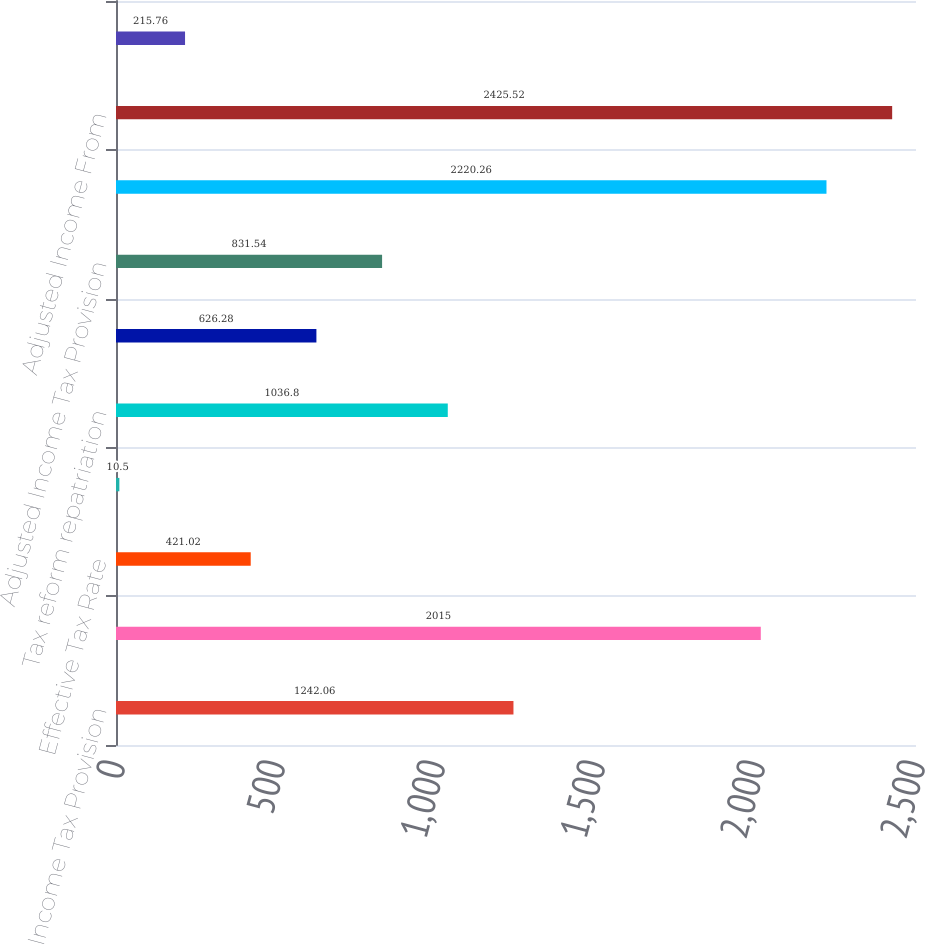Convert chart. <chart><loc_0><loc_0><loc_500><loc_500><bar_chart><fcel>Income Tax Provision<fcel>Income From Continuing<fcel>Effective Tax Rate<fcel>Pension settlement loss<fcel>Tax reform repatriation<fcel>Tax reform adjustment related<fcel>Adjusted Income Tax Provision<fcel>Income from Continuing<fcel>Adjusted Income From<fcel>Adjusted Effective Tax Rate<nl><fcel>1242.06<fcel>2015<fcel>421.02<fcel>10.5<fcel>1036.8<fcel>626.28<fcel>831.54<fcel>2220.26<fcel>2425.52<fcel>215.76<nl></chart> 